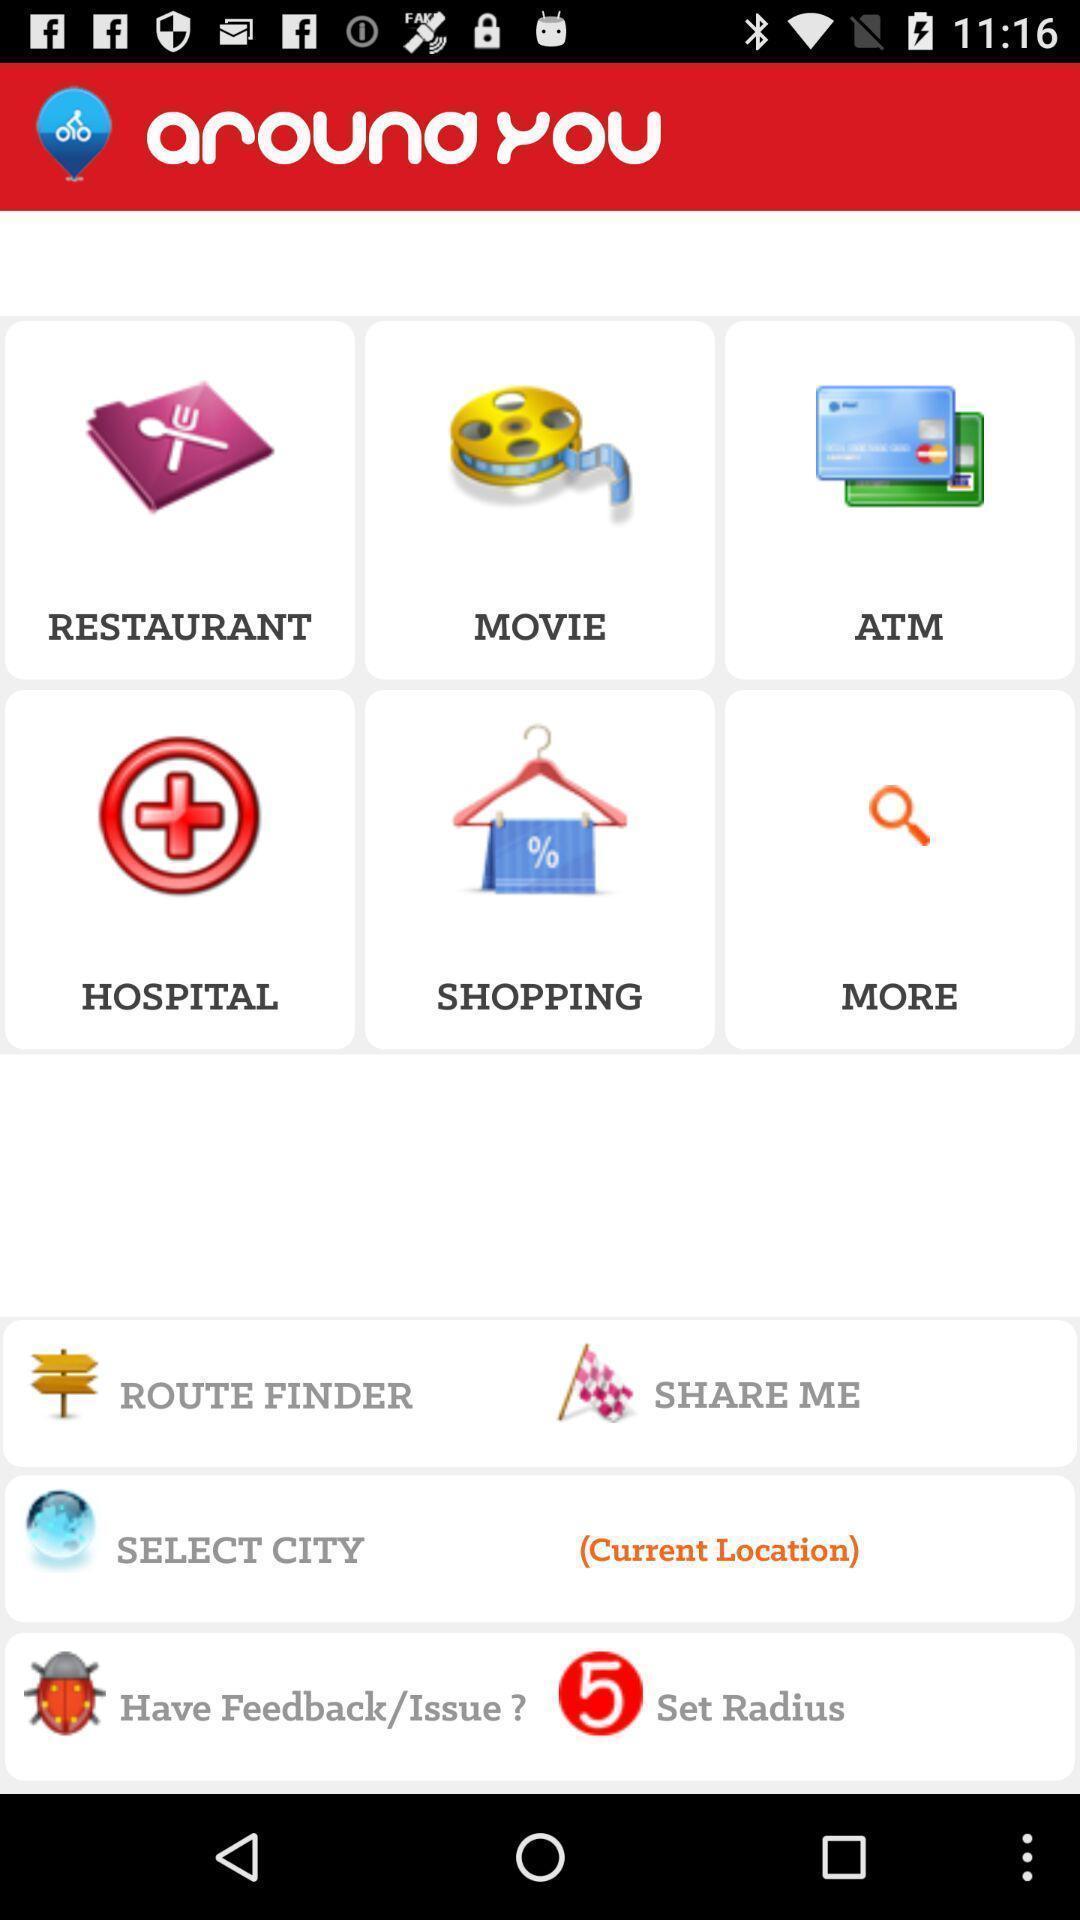Please provide a description for this image. Page showing information on places around. 